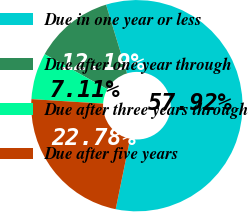Convert chart to OTSL. <chart><loc_0><loc_0><loc_500><loc_500><pie_chart><fcel>Due in one year or less<fcel>Due after one year through<fcel>Due after three years through<fcel>Due after five years<nl><fcel>57.92%<fcel>12.19%<fcel>7.11%<fcel>22.78%<nl></chart> 